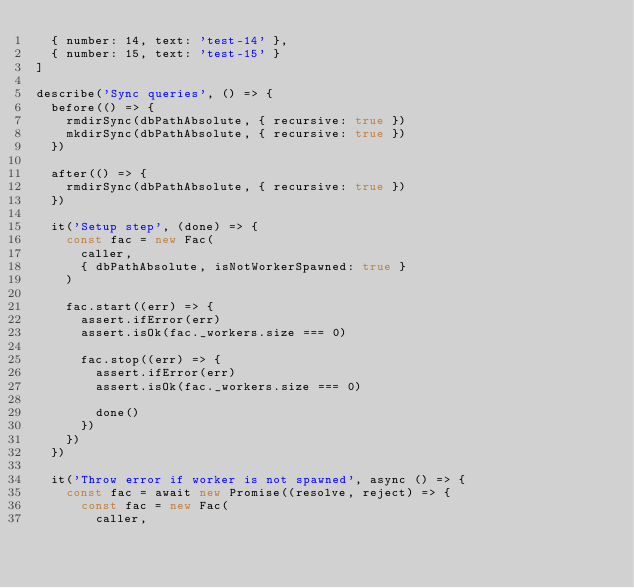Convert code to text. <code><loc_0><loc_0><loc_500><loc_500><_JavaScript_>  { number: 14, text: 'test-14' },
  { number: 15, text: 'test-15' }
]

describe('Sync queries', () => {
  before(() => {
    rmdirSync(dbPathAbsolute, { recursive: true })
    mkdirSync(dbPathAbsolute, { recursive: true })
  })

  after(() => {
    rmdirSync(dbPathAbsolute, { recursive: true })
  })

  it('Setup step', (done) => {
    const fac = new Fac(
      caller,
      { dbPathAbsolute, isNotWorkerSpawned: true }
    )

    fac.start((err) => {
      assert.ifError(err)
      assert.isOk(fac._workers.size === 0)

      fac.stop((err) => {
        assert.ifError(err)
        assert.isOk(fac._workers.size === 0)

        done()
      })
    })
  })

  it('Throw error if worker is not spawned', async () => {
    const fac = await new Promise((resolve, reject) => {
      const fac = new Fac(
        caller,</code> 